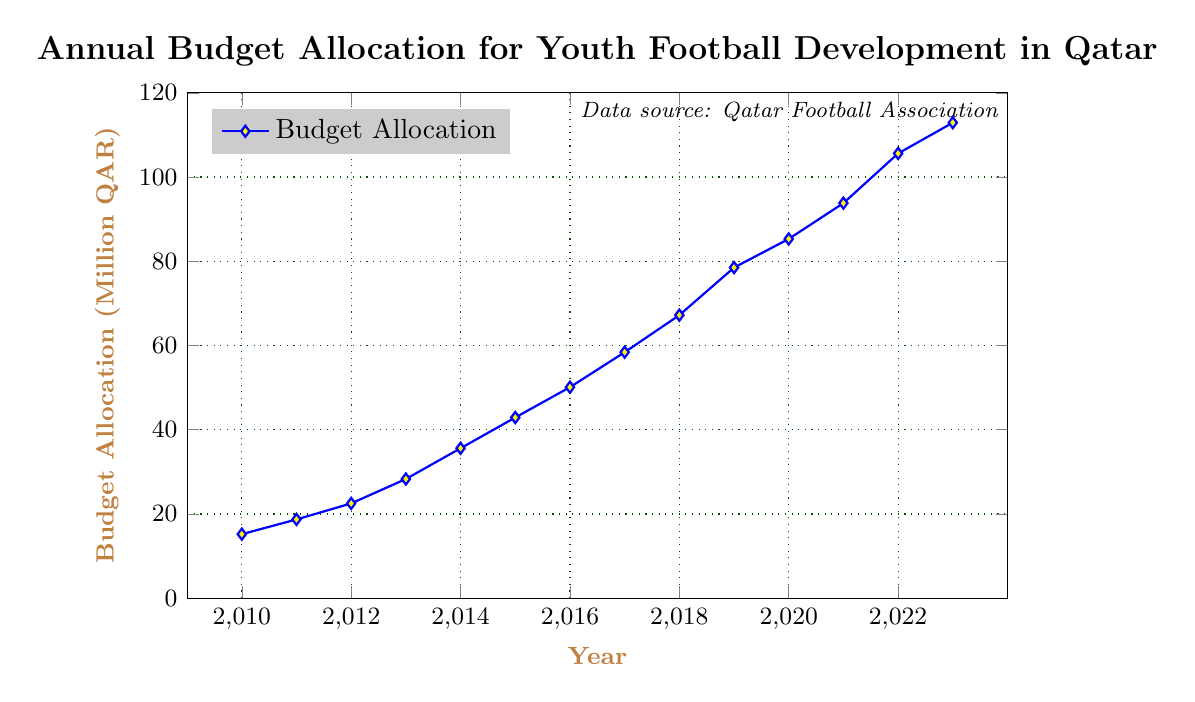What's the trend in the budget allocation for youth football development in Qatar from 2010 to 2023? From the figure, we observe a continuous upward trend in the budget allocation from 2010 to 2023. Each year, the allocation increases compared to the previous year.
Answer: Increasing How much did the budget allocation increase from 2010 to 2023? The budget allocation in 2010 was 15.2 million QAR, and in 2023 it was 112.9 million QAR. The increase is 112.9 - 15.2 = 97.7 million QAR.
Answer: 97.7 million QAR What was the budget allocation for youth football development in the year the World Cup was announced, 2010? The corresponding point in the figure for the year 2010 shows a budget allocation of 15.2 million QAR.
Answer: 15.2 million QAR In which year did the budget allocation surpass 50 million QAR for the first time? Looking at the figure, the budget allocation went past 50 million QAR between 2015 and 2016. Specifically, it was 50.1 million QAR in 2016.
Answer: 2016 How much more was allocated in 2023 compared to 2015? The budget in 2015 was 42.9 million QAR, and in 2023 it was 112.9 million QAR. The difference is 112.9 - 42.9 = 70 million QAR.
Answer: 70 million QAR What is the average annual budget allocation from 2010 to 2023? Sum the budget allocations from 2010 to 2023 and then divide by the number of years (14). (15.2 + 18.7 + 22.5 + 28.3 + 35.6 + 42.9 + 50.1 + 58.4 + 67.2 + 78.5 + 85.3 + 93.8 + 105.6 + 112.9) / 14 ≈ 56.33 million QAR
Answer: 56.33 million QAR Which year saw the highest increase in budget allocation compared to the previous year? Examine the differences between consecutive years in the figure. The largest increase is from 2018 to 2019, where the allocation jumped from 67.2 to 78.5 million QAR. The increase is 78.5 - 67.2 = 11.3 million QAR.
Answer: 2019 What visual cue indicates the budget allocation data points in the figure? The budget allocation data points are marked by diamond shapes filled with yellow and connected by a blue line.
Answer: Diamond shapes with yellow fill Which year had a budget allocation just below 30 million QAR? From the figure, the budget allocation was just below 30 million QAR in 2013 (28.3 million QAR).
Answer: 2013 By how much did the budget allocation increase from 2021 to 2022? The budget allocation in 2021 was 93.8 million QAR and in 2022 it was 105.6 million QAR. The increase is 105.6 - 93.8 = 11.8 million QAR.
Answer: 11.8 million QAR 